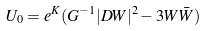<formula> <loc_0><loc_0><loc_500><loc_500>U _ { 0 } = e ^ { K } ( G ^ { - 1 } | D W | ^ { 2 } - 3 W \bar { W } )</formula> 